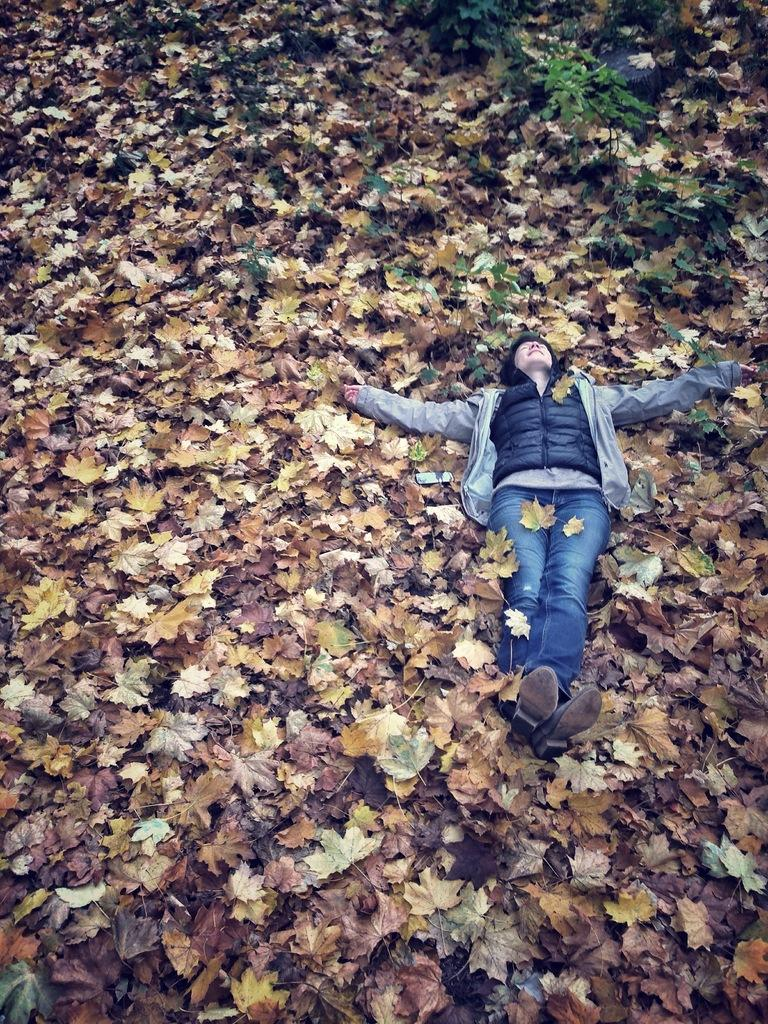What is the position of the person in the image? There is a person lying on the ground in the image. What type of vegetation can be seen in the image? There are plants in the image. What else is present on the ground in the image? Leaves are present on the ground in the image. What type of impulse can be seen affecting the plants in the image? There is no impulse affecting the plants in the image; they are stationary. How many trucks are visible in the image? There are no trucks present in the image. 